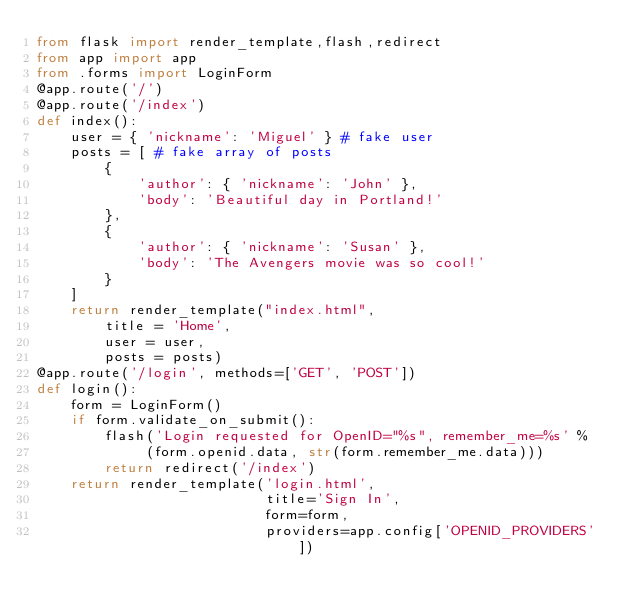<code> <loc_0><loc_0><loc_500><loc_500><_Python_>from flask import render_template,flash,redirect
from app import app
from .forms import LoginForm
@app.route('/')
@app.route('/index')
def index():
    user = { 'nickname': 'Miguel' } # fake user
    posts = [ # fake array of posts
        {
            'author': { 'nickname': 'John' },
            'body': 'Beautiful day in Portland!'
        },
        {
            'author': { 'nickname': 'Susan' },
            'body': 'The Avengers movie was so cool!'
        }
    ]
    return render_template("index.html",
        title = 'Home',
        user = user,
        posts = posts)
@app.route('/login', methods=['GET', 'POST'])
def login():
    form = LoginForm()
    if form.validate_on_submit():
        flash('Login requested for OpenID="%s", remember_me=%s' %
             (form.openid.data, str(form.remember_me.data)))
        return redirect('/index')
    return render_template('login.html', 
                           title='Sign In',
                           form=form,
                           providers=app.config['OPENID_PROVIDERS'])</code> 